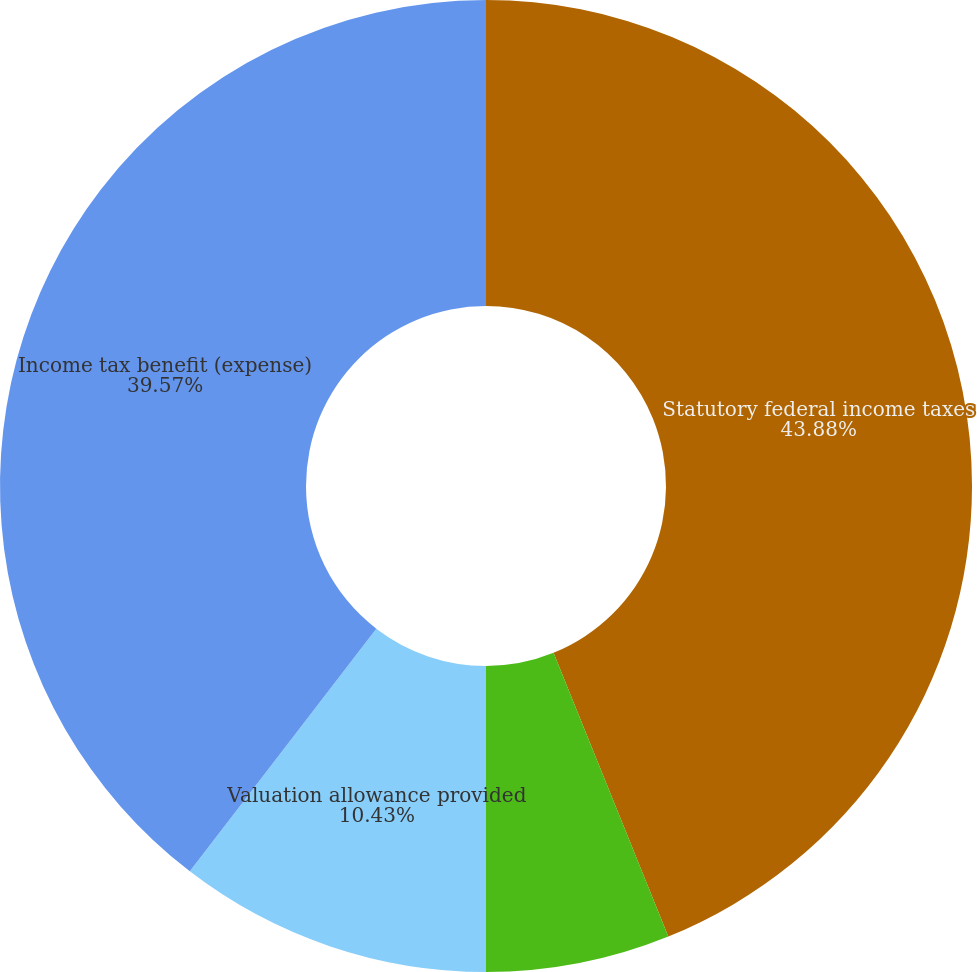Convert chart. <chart><loc_0><loc_0><loc_500><loc_500><pie_chart><fcel>Statutory federal income taxes<fcel>State income taxes net of<fcel>Valuation allowance provided<fcel>Income tax benefit (expense)<nl><fcel>43.88%<fcel>6.12%<fcel>10.43%<fcel>39.57%<nl></chart> 